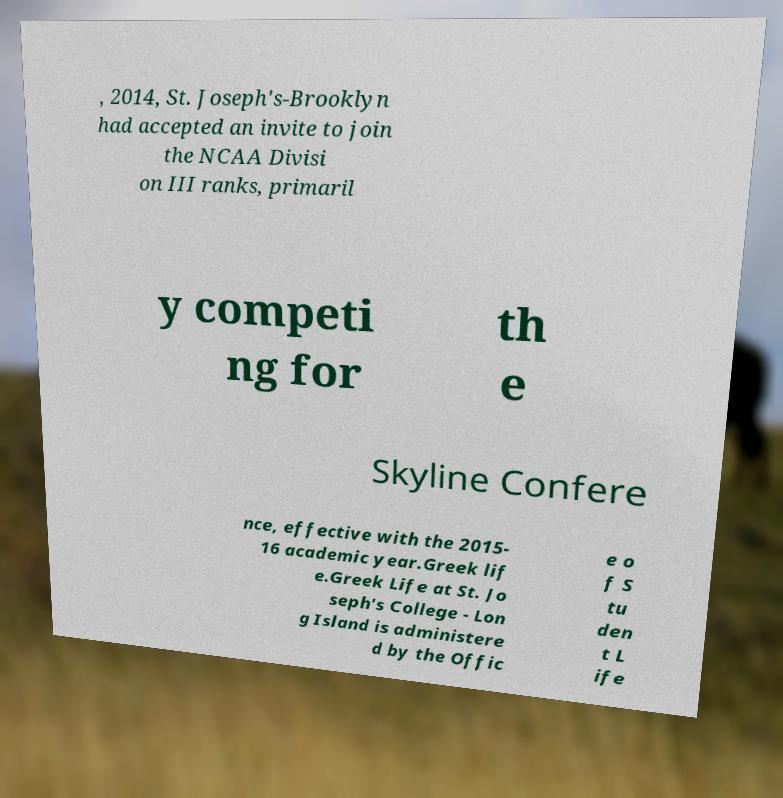Can you accurately transcribe the text from the provided image for me? , 2014, St. Joseph's-Brooklyn had accepted an invite to join the NCAA Divisi on III ranks, primaril y competi ng for th e Skyline Confere nce, effective with the 2015- 16 academic year.Greek lif e.Greek Life at St. Jo seph's College - Lon g Island is administere d by the Offic e o f S tu den t L ife 